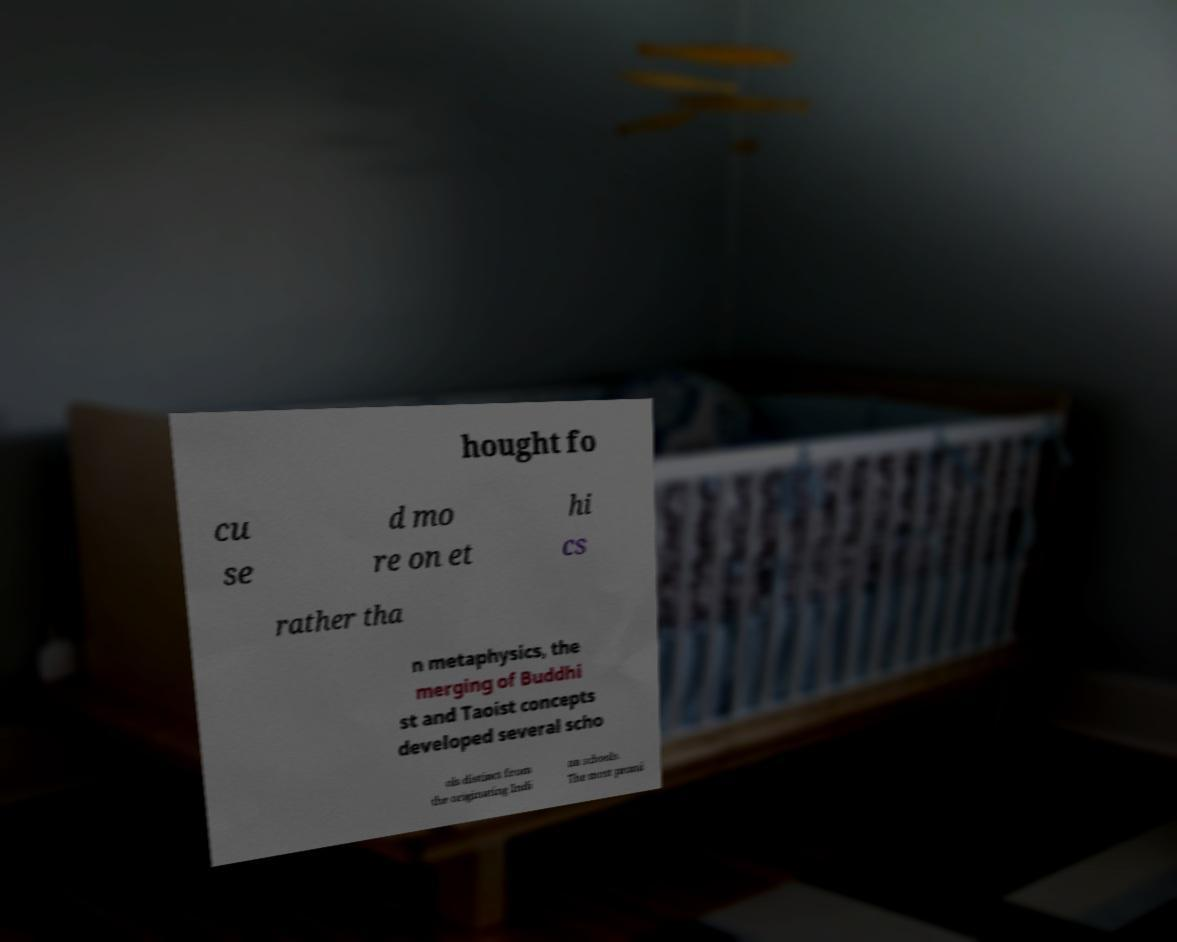Can you read and provide the text displayed in the image?This photo seems to have some interesting text. Can you extract and type it out for me? hought fo cu se d mo re on et hi cs rather tha n metaphysics, the merging of Buddhi st and Taoist concepts developed several scho ols distinct from the originating Indi an schools. The most promi 